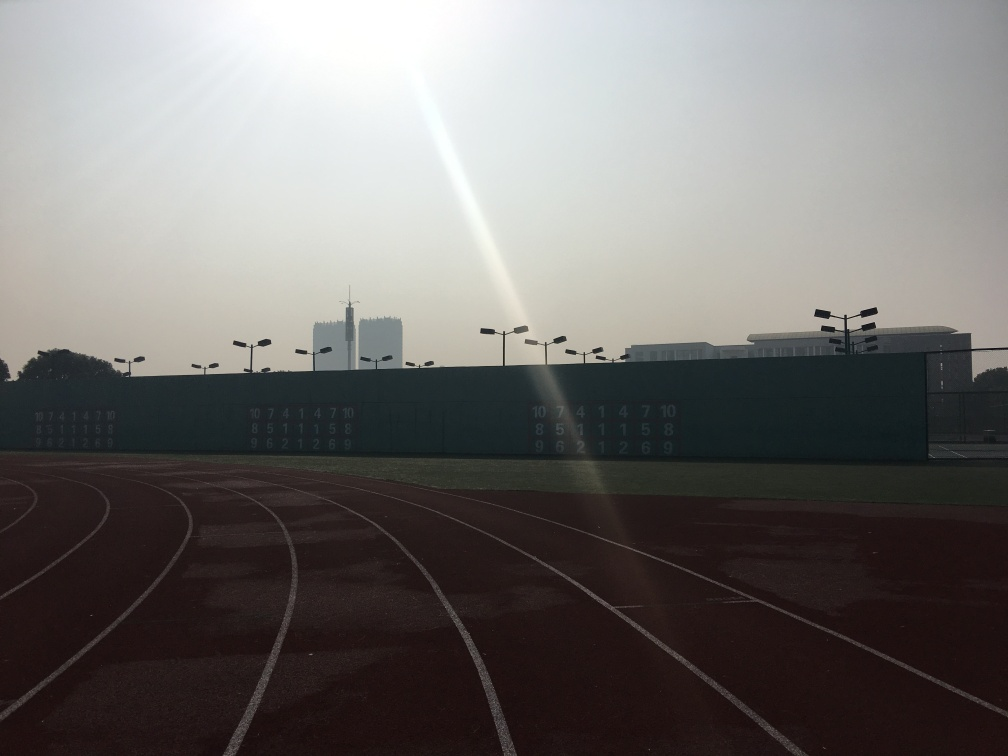What time of day does this image seem to represent, and what clues in the image lead to that conclusion? The image seems to depict early morning or late afternoon, as indicated by the long shadows cast on the running track and the relatively low position of the sun in the sky. The softness and warm color tones of the light suggest the sun is near the horizon, which typically occurs during these times of day. 